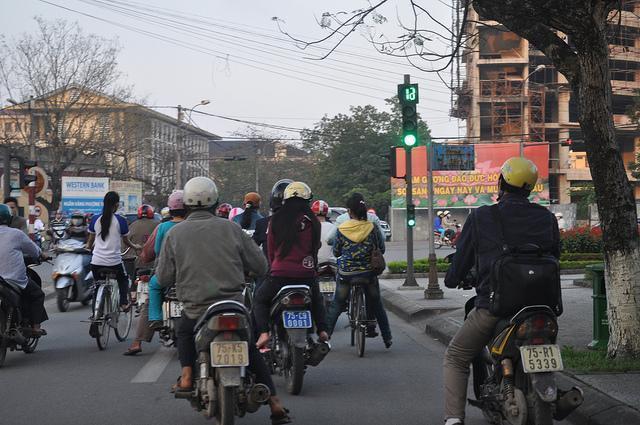What color are the numbers on the top of the pole with the traffic lights?
Make your selection from the four choices given to correctly answer the question.
Options: Red, yellow, green, blue. Green. What country is this street scene likely part of?
Indicate the correct response and explain using: 'Answer: answer
Rationale: rationale.'
Options: Laos, vietnam, cambodia, thailand. Answer: vietnam.
Rationale: This is a country where a lot of people have scooters and bikes 